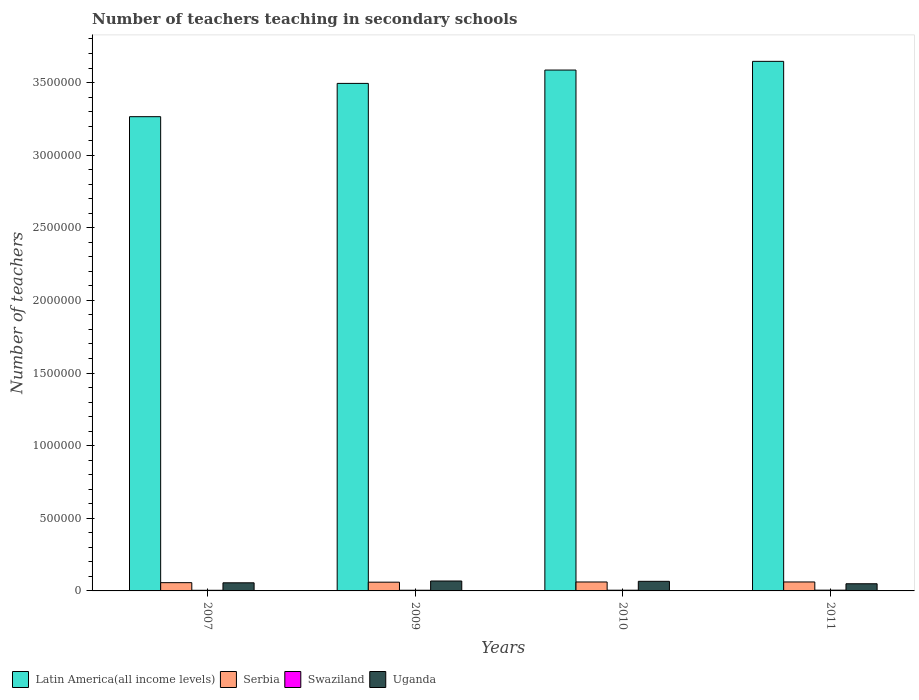How many groups of bars are there?
Offer a very short reply. 4. What is the number of teachers teaching in secondary schools in Uganda in 2009?
Your answer should be very brief. 6.82e+04. Across all years, what is the maximum number of teachers teaching in secondary schools in Uganda?
Offer a terse response. 6.82e+04. Across all years, what is the minimum number of teachers teaching in secondary schools in Uganda?
Provide a short and direct response. 4.93e+04. In which year was the number of teachers teaching in secondary schools in Serbia maximum?
Offer a terse response. 2011. What is the total number of teachers teaching in secondary schools in Uganda in the graph?
Your answer should be compact. 2.39e+05. What is the difference between the number of teachers teaching in secondary schools in Serbia in 2010 and that in 2011?
Make the answer very short. -161. What is the difference between the number of teachers teaching in secondary schools in Latin America(all income levels) in 2010 and the number of teachers teaching in secondary schools in Swaziland in 2009?
Your answer should be compact. 3.58e+06. What is the average number of teachers teaching in secondary schools in Serbia per year?
Give a very brief answer. 6.01e+04. In the year 2007, what is the difference between the number of teachers teaching in secondary schools in Swaziland and number of teachers teaching in secondary schools in Serbia?
Keep it short and to the point. -5.25e+04. What is the ratio of the number of teachers teaching in secondary schools in Uganda in 2007 to that in 2010?
Offer a very short reply. 0.85. Is the difference between the number of teachers teaching in secondary schools in Swaziland in 2010 and 2011 greater than the difference between the number of teachers teaching in secondary schools in Serbia in 2010 and 2011?
Your response must be concise. No. What is the difference between the highest and the second highest number of teachers teaching in secondary schools in Serbia?
Provide a succinct answer. 161. What is the difference between the highest and the lowest number of teachers teaching in secondary schools in Serbia?
Provide a short and direct response. 4813. In how many years, is the number of teachers teaching in secondary schools in Serbia greater than the average number of teachers teaching in secondary schools in Serbia taken over all years?
Offer a very short reply. 3. Is the sum of the number of teachers teaching in secondary schools in Latin America(all income levels) in 2009 and 2010 greater than the maximum number of teachers teaching in secondary schools in Uganda across all years?
Give a very brief answer. Yes. What does the 4th bar from the left in 2009 represents?
Provide a succinct answer. Uganda. What does the 1st bar from the right in 2009 represents?
Offer a terse response. Uganda. Is it the case that in every year, the sum of the number of teachers teaching in secondary schools in Swaziland and number of teachers teaching in secondary schools in Serbia is greater than the number of teachers teaching in secondary schools in Uganda?
Ensure brevity in your answer.  No. How many bars are there?
Provide a succinct answer. 16. How many years are there in the graph?
Give a very brief answer. 4. What is the difference between two consecutive major ticks on the Y-axis?
Your answer should be very brief. 5.00e+05. Are the values on the major ticks of Y-axis written in scientific E-notation?
Your answer should be very brief. No. Where does the legend appear in the graph?
Provide a succinct answer. Bottom left. How many legend labels are there?
Ensure brevity in your answer.  4. How are the legend labels stacked?
Offer a very short reply. Horizontal. What is the title of the graph?
Ensure brevity in your answer.  Number of teachers teaching in secondary schools. What is the label or title of the X-axis?
Make the answer very short. Years. What is the label or title of the Y-axis?
Give a very brief answer. Number of teachers. What is the Number of teachers in Latin America(all income levels) in 2007?
Your response must be concise. 3.27e+06. What is the Number of teachers in Serbia in 2007?
Your answer should be compact. 5.69e+04. What is the Number of teachers in Swaziland in 2007?
Your answer should be compact. 4358. What is the Number of teachers of Uganda in 2007?
Offer a terse response. 5.59e+04. What is the Number of teachers in Latin America(all income levels) in 2009?
Provide a short and direct response. 3.49e+06. What is the Number of teachers in Serbia in 2009?
Keep it short and to the point. 6.02e+04. What is the Number of teachers in Swaziland in 2009?
Make the answer very short. 4717. What is the Number of teachers in Uganda in 2009?
Your response must be concise. 6.82e+04. What is the Number of teachers in Latin America(all income levels) in 2010?
Keep it short and to the point. 3.59e+06. What is the Number of teachers of Serbia in 2010?
Offer a terse response. 6.15e+04. What is the Number of teachers of Swaziland in 2010?
Provide a short and direct response. 4890. What is the Number of teachers in Uganda in 2010?
Offer a terse response. 6.61e+04. What is the Number of teachers of Latin America(all income levels) in 2011?
Offer a very short reply. 3.65e+06. What is the Number of teachers in Serbia in 2011?
Make the answer very short. 6.17e+04. What is the Number of teachers in Swaziland in 2011?
Your response must be concise. 5250. What is the Number of teachers of Uganda in 2011?
Your answer should be very brief. 4.93e+04. Across all years, what is the maximum Number of teachers of Latin America(all income levels)?
Offer a terse response. 3.65e+06. Across all years, what is the maximum Number of teachers of Serbia?
Offer a terse response. 6.17e+04. Across all years, what is the maximum Number of teachers in Swaziland?
Your answer should be compact. 5250. Across all years, what is the maximum Number of teachers in Uganda?
Offer a terse response. 6.82e+04. Across all years, what is the minimum Number of teachers in Latin America(all income levels)?
Keep it short and to the point. 3.27e+06. Across all years, what is the minimum Number of teachers of Serbia?
Provide a short and direct response. 5.69e+04. Across all years, what is the minimum Number of teachers of Swaziland?
Your answer should be very brief. 4358. Across all years, what is the minimum Number of teachers in Uganda?
Make the answer very short. 4.93e+04. What is the total Number of teachers of Latin America(all income levels) in the graph?
Your answer should be compact. 1.40e+07. What is the total Number of teachers of Serbia in the graph?
Your response must be concise. 2.40e+05. What is the total Number of teachers in Swaziland in the graph?
Offer a very short reply. 1.92e+04. What is the total Number of teachers in Uganda in the graph?
Your answer should be compact. 2.39e+05. What is the difference between the Number of teachers in Latin America(all income levels) in 2007 and that in 2009?
Ensure brevity in your answer.  -2.29e+05. What is the difference between the Number of teachers of Serbia in 2007 and that in 2009?
Offer a very short reply. -3313. What is the difference between the Number of teachers in Swaziland in 2007 and that in 2009?
Make the answer very short. -359. What is the difference between the Number of teachers in Uganda in 2007 and that in 2009?
Offer a terse response. -1.24e+04. What is the difference between the Number of teachers in Latin America(all income levels) in 2007 and that in 2010?
Give a very brief answer. -3.21e+05. What is the difference between the Number of teachers in Serbia in 2007 and that in 2010?
Make the answer very short. -4652. What is the difference between the Number of teachers in Swaziland in 2007 and that in 2010?
Provide a short and direct response. -532. What is the difference between the Number of teachers of Uganda in 2007 and that in 2010?
Give a very brief answer. -1.02e+04. What is the difference between the Number of teachers of Latin America(all income levels) in 2007 and that in 2011?
Give a very brief answer. -3.81e+05. What is the difference between the Number of teachers in Serbia in 2007 and that in 2011?
Offer a terse response. -4813. What is the difference between the Number of teachers of Swaziland in 2007 and that in 2011?
Keep it short and to the point. -892. What is the difference between the Number of teachers of Uganda in 2007 and that in 2011?
Ensure brevity in your answer.  6539. What is the difference between the Number of teachers in Latin America(all income levels) in 2009 and that in 2010?
Make the answer very short. -9.19e+04. What is the difference between the Number of teachers in Serbia in 2009 and that in 2010?
Your answer should be compact. -1339. What is the difference between the Number of teachers of Swaziland in 2009 and that in 2010?
Your response must be concise. -173. What is the difference between the Number of teachers of Uganda in 2009 and that in 2010?
Make the answer very short. 2124. What is the difference between the Number of teachers of Latin America(all income levels) in 2009 and that in 2011?
Ensure brevity in your answer.  -1.52e+05. What is the difference between the Number of teachers in Serbia in 2009 and that in 2011?
Provide a succinct answer. -1500. What is the difference between the Number of teachers of Swaziland in 2009 and that in 2011?
Ensure brevity in your answer.  -533. What is the difference between the Number of teachers in Uganda in 2009 and that in 2011?
Your response must be concise. 1.89e+04. What is the difference between the Number of teachers in Latin America(all income levels) in 2010 and that in 2011?
Your answer should be compact. -5.99e+04. What is the difference between the Number of teachers in Serbia in 2010 and that in 2011?
Offer a terse response. -161. What is the difference between the Number of teachers in Swaziland in 2010 and that in 2011?
Your answer should be very brief. -360. What is the difference between the Number of teachers of Uganda in 2010 and that in 2011?
Offer a terse response. 1.68e+04. What is the difference between the Number of teachers of Latin America(all income levels) in 2007 and the Number of teachers of Serbia in 2009?
Provide a succinct answer. 3.20e+06. What is the difference between the Number of teachers of Latin America(all income levels) in 2007 and the Number of teachers of Swaziland in 2009?
Provide a short and direct response. 3.26e+06. What is the difference between the Number of teachers of Latin America(all income levels) in 2007 and the Number of teachers of Uganda in 2009?
Your answer should be very brief. 3.20e+06. What is the difference between the Number of teachers of Serbia in 2007 and the Number of teachers of Swaziland in 2009?
Give a very brief answer. 5.22e+04. What is the difference between the Number of teachers in Serbia in 2007 and the Number of teachers in Uganda in 2009?
Ensure brevity in your answer.  -1.13e+04. What is the difference between the Number of teachers in Swaziland in 2007 and the Number of teachers in Uganda in 2009?
Provide a succinct answer. -6.39e+04. What is the difference between the Number of teachers in Latin America(all income levels) in 2007 and the Number of teachers in Serbia in 2010?
Make the answer very short. 3.20e+06. What is the difference between the Number of teachers of Latin America(all income levels) in 2007 and the Number of teachers of Swaziland in 2010?
Offer a very short reply. 3.26e+06. What is the difference between the Number of teachers in Latin America(all income levels) in 2007 and the Number of teachers in Uganda in 2010?
Keep it short and to the point. 3.20e+06. What is the difference between the Number of teachers of Serbia in 2007 and the Number of teachers of Swaziland in 2010?
Provide a succinct answer. 5.20e+04. What is the difference between the Number of teachers in Serbia in 2007 and the Number of teachers in Uganda in 2010?
Provide a short and direct response. -9202. What is the difference between the Number of teachers of Swaziland in 2007 and the Number of teachers of Uganda in 2010?
Provide a short and direct response. -6.17e+04. What is the difference between the Number of teachers in Latin America(all income levels) in 2007 and the Number of teachers in Serbia in 2011?
Offer a terse response. 3.20e+06. What is the difference between the Number of teachers in Latin America(all income levels) in 2007 and the Number of teachers in Swaziland in 2011?
Offer a very short reply. 3.26e+06. What is the difference between the Number of teachers in Latin America(all income levels) in 2007 and the Number of teachers in Uganda in 2011?
Offer a terse response. 3.22e+06. What is the difference between the Number of teachers of Serbia in 2007 and the Number of teachers of Swaziland in 2011?
Make the answer very short. 5.16e+04. What is the difference between the Number of teachers in Serbia in 2007 and the Number of teachers in Uganda in 2011?
Your response must be concise. 7567. What is the difference between the Number of teachers in Swaziland in 2007 and the Number of teachers in Uganda in 2011?
Ensure brevity in your answer.  -4.50e+04. What is the difference between the Number of teachers in Latin America(all income levels) in 2009 and the Number of teachers in Serbia in 2010?
Your answer should be very brief. 3.43e+06. What is the difference between the Number of teachers of Latin America(all income levels) in 2009 and the Number of teachers of Swaziland in 2010?
Offer a very short reply. 3.49e+06. What is the difference between the Number of teachers in Latin America(all income levels) in 2009 and the Number of teachers in Uganda in 2010?
Provide a succinct answer. 3.43e+06. What is the difference between the Number of teachers in Serbia in 2009 and the Number of teachers in Swaziland in 2010?
Keep it short and to the point. 5.53e+04. What is the difference between the Number of teachers in Serbia in 2009 and the Number of teachers in Uganda in 2010?
Offer a very short reply. -5889. What is the difference between the Number of teachers of Swaziland in 2009 and the Number of teachers of Uganda in 2010?
Give a very brief answer. -6.14e+04. What is the difference between the Number of teachers of Latin America(all income levels) in 2009 and the Number of teachers of Serbia in 2011?
Ensure brevity in your answer.  3.43e+06. What is the difference between the Number of teachers in Latin America(all income levels) in 2009 and the Number of teachers in Swaziland in 2011?
Provide a succinct answer. 3.49e+06. What is the difference between the Number of teachers of Latin America(all income levels) in 2009 and the Number of teachers of Uganda in 2011?
Ensure brevity in your answer.  3.44e+06. What is the difference between the Number of teachers of Serbia in 2009 and the Number of teachers of Swaziland in 2011?
Give a very brief answer. 5.50e+04. What is the difference between the Number of teachers in Serbia in 2009 and the Number of teachers in Uganda in 2011?
Give a very brief answer. 1.09e+04. What is the difference between the Number of teachers in Swaziland in 2009 and the Number of teachers in Uganda in 2011?
Keep it short and to the point. -4.46e+04. What is the difference between the Number of teachers of Latin America(all income levels) in 2010 and the Number of teachers of Serbia in 2011?
Provide a succinct answer. 3.52e+06. What is the difference between the Number of teachers in Latin America(all income levels) in 2010 and the Number of teachers in Swaziland in 2011?
Your response must be concise. 3.58e+06. What is the difference between the Number of teachers of Latin America(all income levels) in 2010 and the Number of teachers of Uganda in 2011?
Offer a very short reply. 3.54e+06. What is the difference between the Number of teachers in Serbia in 2010 and the Number of teachers in Swaziland in 2011?
Your answer should be compact. 5.63e+04. What is the difference between the Number of teachers in Serbia in 2010 and the Number of teachers in Uganda in 2011?
Your answer should be very brief. 1.22e+04. What is the difference between the Number of teachers in Swaziland in 2010 and the Number of teachers in Uganda in 2011?
Make the answer very short. -4.44e+04. What is the average Number of teachers of Latin America(all income levels) per year?
Provide a succinct answer. 3.50e+06. What is the average Number of teachers in Serbia per year?
Your answer should be compact. 6.01e+04. What is the average Number of teachers of Swaziland per year?
Ensure brevity in your answer.  4803.75. What is the average Number of teachers in Uganda per year?
Offer a very short reply. 5.99e+04. In the year 2007, what is the difference between the Number of teachers of Latin America(all income levels) and Number of teachers of Serbia?
Your answer should be compact. 3.21e+06. In the year 2007, what is the difference between the Number of teachers of Latin America(all income levels) and Number of teachers of Swaziland?
Offer a terse response. 3.26e+06. In the year 2007, what is the difference between the Number of teachers in Latin America(all income levels) and Number of teachers in Uganda?
Offer a terse response. 3.21e+06. In the year 2007, what is the difference between the Number of teachers in Serbia and Number of teachers in Swaziland?
Give a very brief answer. 5.25e+04. In the year 2007, what is the difference between the Number of teachers of Serbia and Number of teachers of Uganda?
Offer a terse response. 1028. In the year 2007, what is the difference between the Number of teachers in Swaziland and Number of teachers in Uganda?
Your answer should be compact. -5.15e+04. In the year 2009, what is the difference between the Number of teachers in Latin America(all income levels) and Number of teachers in Serbia?
Provide a succinct answer. 3.43e+06. In the year 2009, what is the difference between the Number of teachers of Latin America(all income levels) and Number of teachers of Swaziland?
Keep it short and to the point. 3.49e+06. In the year 2009, what is the difference between the Number of teachers of Latin America(all income levels) and Number of teachers of Uganda?
Keep it short and to the point. 3.43e+06. In the year 2009, what is the difference between the Number of teachers in Serbia and Number of teachers in Swaziland?
Make the answer very short. 5.55e+04. In the year 2009, what is the difference between the Number of teachers of Serbia and Number of teachers of Uganda?
Offer a very short reply. -8013. In the year 2009, what is the difference between the Number of teachers in Swaziland and Number of teachers in Uganda?
Offer a terse response. -6.35e+04. In the year 2010, what is the difference between the Number of teachers in Latin America(all income levels) and Number of teachers in Serbia?
Your answer should be very brief. 3.52e+06. In the year 2010, what is the difference between the Number of teachers of Latin America(all income levels) and Number of teachers of Swaziland?
Offer a terse response. 3.58e+06. In the year 2010, what is the difference between the Number of teachers in Latin America(all income levels) and Number of teachers in Uganda?
Your answer should be compact. 3.52e+06. In the year 2010, what is the difference between the Number of teachers in Serbia and Number of teachers in Swaziland?
Your answer should be compact. 5.67e+04. In the year 2010, what is the difference between the Number of teachers in Serbia and Number of teachers in Uganda?
Give a very brief answer. -4550. In the year 2010, what is the difference between the Number of teachers of Swaziland and Number of teachers of Uganda?
Your answer should be very brief. -6.12e+04. In the year 2011, what is the difference between the Number of teachers in Latin America(all income levels) and Number of teachers in Serbia?
Offer a terse response. 3.58e+06. In the year 2011, what is the difference between the Number of teachers in Latin America(all income levels) and Number of teachers in Swaziland?
Keep it short and to the point. 3.64e+06. In the year 2011, what is the difference between the Number of teachers of Latin America(all income levels) and Number of teachers of Uganda?
Offer a very short reply. 3.60e+06. In the year 2011, what is the difference between the Number of teachers of Serbia and Number of teachers of Swaziland?
Give a very brief answer. 5.65e+04. In the year 2011, what is the difference between the Number of teachers of Serbia and Number of teachers of Uganda?
Provide a short and direct response. 1.24e+04. In the year 2011, what is the difference between the Number of teachers in Swaziland and Number of teachers in Uganda?
Provide a succinct answer. -4.41e+04. What is the ratio of the Number of teachers in Latin America(all income levels) in 2007 to that in 2009?
Your response must be concise. 0.93. What is the ratio of the Number of teachers in Serbia in 2007 to that in 2009?
Keep it short and to the point. 0.94. What is the ratio of the Number of teachers in Swaziland in 2007 to that in 2009?
Ensure brevity in your answer.  0.92. What is the ratio of the Number of teachers in Uganda in 2007 to that in 2009?
Give a very brief answer. 0.82. What is the ratio of the Number of teachers of Latin America(all income levels) in 2007 to that in 2010?
Ensure brevity in your answer.  0.91. What is the ratio of the Number of teachers in Serbia in 2007 to that in 2010?
Make the answer very short. 0.92. What is the ratio of the Number of teachers in Swaziland in 2007 to that in 2010?
Your response must be concise. 0.89. What is the ratio of the Number of teachers of Uganda in 2007 to that in 2010?
Keep it short and to the point. 0.85. What is the ratio of the Number of teachers in Latin America(all income levels) in 2007 to that in 2011?
Your answer should be compact. 0.9. What is the ratio of the Number of teachers of Serbia in 2007 to that in 2011?
Make the answer very short. 0.92. What is the ratio of the Number of teachers in Swaziland in 2007 to that in 2011?
Make the answer very short. 0.83. What is the ratio of the Number of teachers of Uganda in 2007 to that in 2011?
Provide a short and direct response. 1.13. What is the ratio of the Number of teachers of Latin America(all income levels) in 2009 to that in 2010?
Make the answer very short. 0.97. What is the ratio of the Number of teachers in Serbia in 2009 to that in 2010?
Ensure brevity in your answer.  0.98. What is the ratio of the Number of teachers of Swaziland in 2009 to that in 2010?
Offer a very short reply. 0.96. What is the ratio of the Number of teachers of Uganda in 2009 to that in 2010?
Ensure brevity in your answer.  1.03. What is the ratio of the Number of teachers in Latin America(all income levels) in 2009 to that in 2011?
Your answer should be very brief. 0.96. What is the ratio of the Number of teachers in Serbia in 2009 to that in 2011?
Your response must be concise. 0.98. What is the ratio of the Number of teachers of Swaziland in 2009 to that in 2011?
Your answer should be compact. 0.9. What is the ratio of the Number of teachers of Uganda in 2009 to that in 2011?
Offer a very short reply. 1.38. What is the ratio of the Number of teachers in Latin America(all income levels) in 2010 to that in 2011?
Provide a succinct answer. 0.98. What is the ratio of the Number of teachers in Swaziland in 2010 to that in 2011?
Offer a very short reply. 0.93. What is the ratio of the Number of teachers of Uganda in 2010 to that in 2011?
Make the answer very short. 1.34. What is the difference between the highest and the second highest Number of teachers in Latin America(all income levels)?
Keep it short and to the point. 5.99e+04. What is the difference between the highest and the second highest Number of teachers in Serbia?
Your answer should be very brief. 161. What is the difference between the highest and the second highest Number of teachers of Swaziland?
Your response must be concise. 360. What is the difference between the highest and the second highest Number of teachers of Uganda?
Give a very brief answer. 2124. What is the difference between the highest and the lowest Number of teachers in Latin America(all income levels)?
Keep it short and to the point. 3.81e+05. What is the difference between the highest and the lowest Number of teachers of Serbia?
Give a very brief answer. 4813. What is the difference between the highest and the lowest Number of teachers of Swaziland?
Provide a succinct answer. 892. What is the difference between the highest and the lowest Number of teachers of Uganda?
Provide a succinct answer. 1.89e+04. 